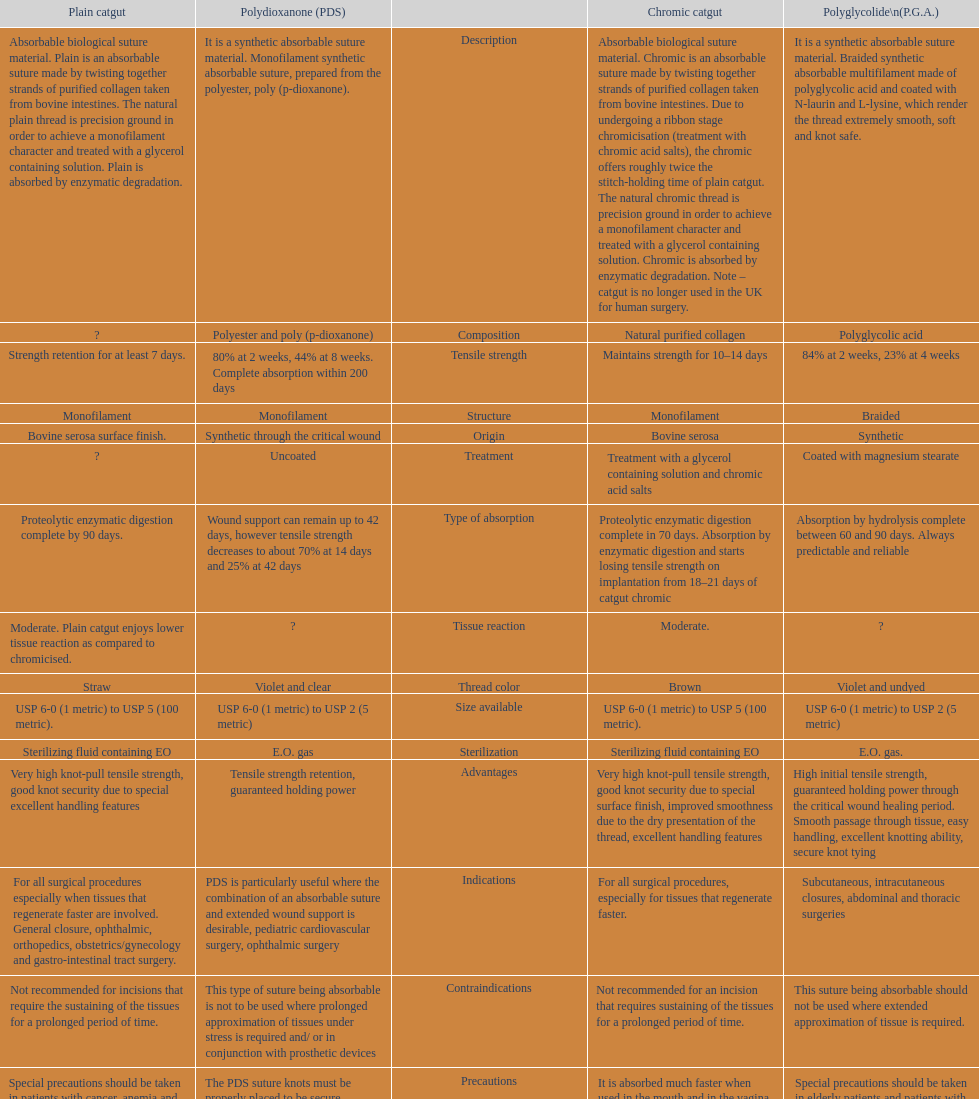Which suture can remain to at most 42 days Polydioxanone (PDS). 